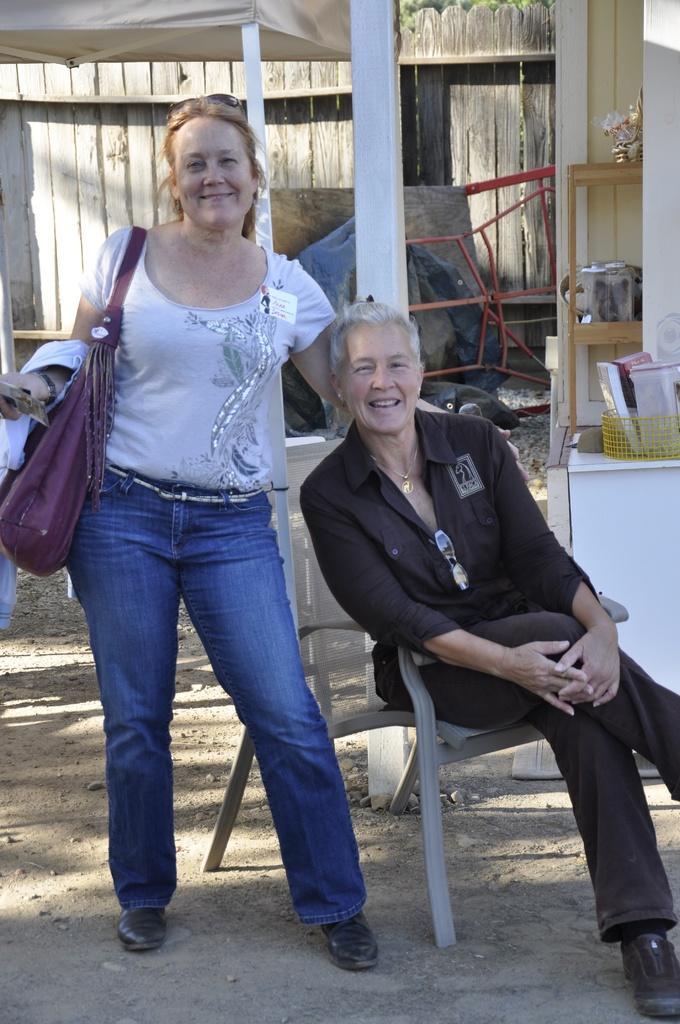Describe this image in one or two sentences. In this image there is one man and one woman and in the background there is a tent, wooden wall and some objects. On the right side there is one table, on the table there is one basket. In that basket there are some objects, and at the bottom there is sand. 